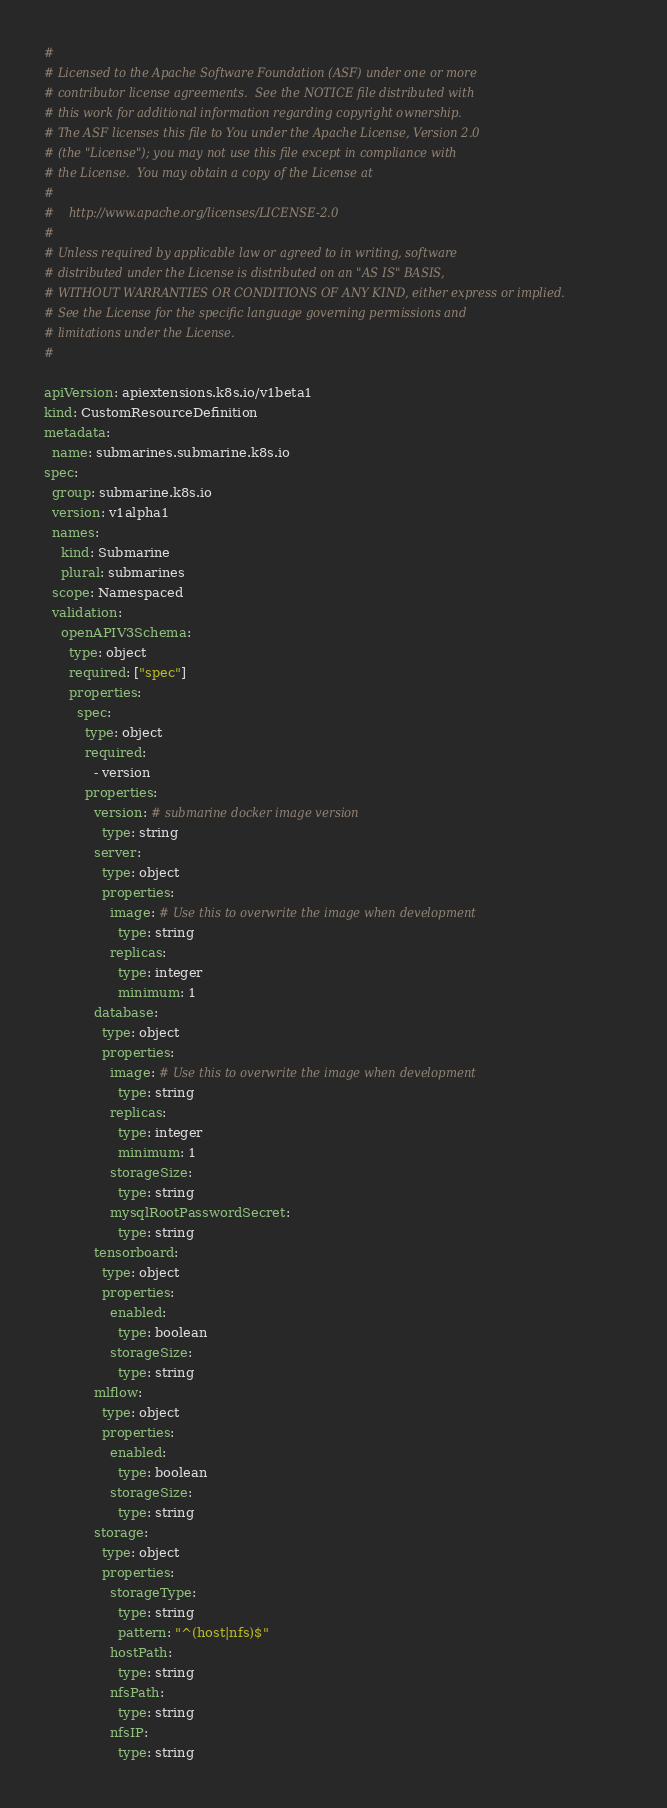<code> <loc_0><loc_0><loc_500><loc_500><_YAML_>#
# Licensed to the Apache Software Foundation (ASF) under one or more
# contributor license agreements.  See the NOTICE file distributed with
# this work for additional information regarding copyright ownership.
# The ASF licenses this file to You under the Apache License, Version 2.0
# (the "License"); you may not use this file except in compliance with
# the License.  You may obtain a copy of the License at
#
#    http://www.apache.org/licenses/LICENSE-2.0
#
# Unless required by applicable law or agreed to in writing, software
# distributed under the License is distributed on an "AS IS" BASIS,
# WITHOUT WARRANTIES OR CONDITIONS OF ANY KIND, either express or implied.
# See the License for the specific language governing permissions and
# limitations under the License.
#

apiVersion: apiextensions.k8s.io/v1beta1
kind: CustomResourceDefinition
metadata:
  name: submarines.submarine.k8s.io
spec:
  group: submarine.k8s.io
  version: v1alpha1
  names:
    kind: Submarine
    plural: submarines
  scope: Namespaced
  validation:
    openAPIV3Schema:
      type: object
      required: ["spec"]
      properties:
        spec:
          type: object
          required:
            - version
          properties:
            version: # submarine docker image version
              type: string
            server:
              type: object
              properties:
                image: # Use this to overwrite the image when development
                  type: string
                replicas:
                  type: integer
                  minimum: 1
            database:
              type: object
              properties:
                image: # Use this to overwrite the image when development
                  type: string
                replicas:
                  type: integer
                  minimum: 1
                storageSize:
                  type: string
                mysqlRootPasswordSecret:
                  type: string
            tensorboard:
              type: object
              properties:
                enabled:
                  type: boolean
                storageSize:
                  type: string
            mlflow:
              type: object
              properties:
                enabled:
                  type: boolean
                storageSize:
                  type: string
            storage:
              type: object
              properties:
                storageType:
                  type: string
                  pattern: "^(host|nfs)$"
                hostPath:
                  type: string
                nfsPath:
                  type: string
                nfsIP:
                  type: string
</code> 